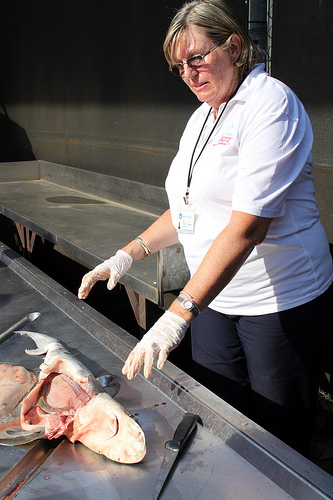<image>
Is the shark guts next to the human? Yes. The shark guts is positioned adjacent to the human, located nearby in the same general area. 